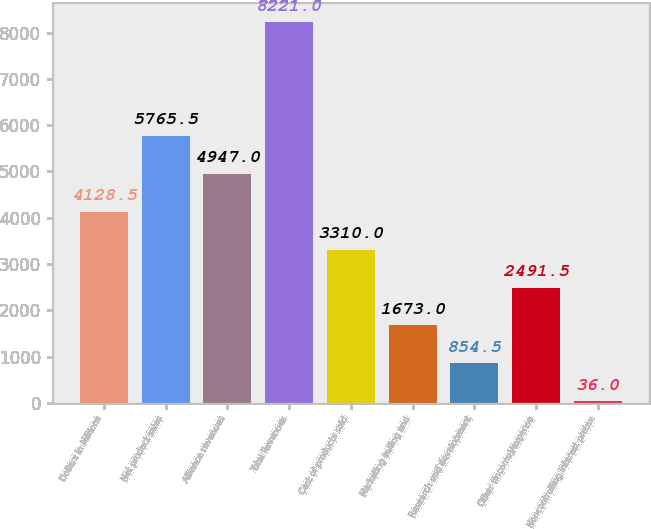<chart> <loc_0><loc_0><loc_500><loc_500><bar_chart><fcel>Dollars in Millions<fcel>Net product sales<fcel>Alliance revenues<fcel>Total Revenues<fcel>Cost of products sold<fcel>Marketing selling and<fcel>Research and development<fcel>Other (income)/expense<fcel>Noncontrolling interest pretax<nl><fcel>4128.5<fcel>5765.5<fcel>4947<fcel>8221<fcel>3310<fcel>1673<fcel>854.5<fcel>2491.5<fcel>36<nl></chart> 